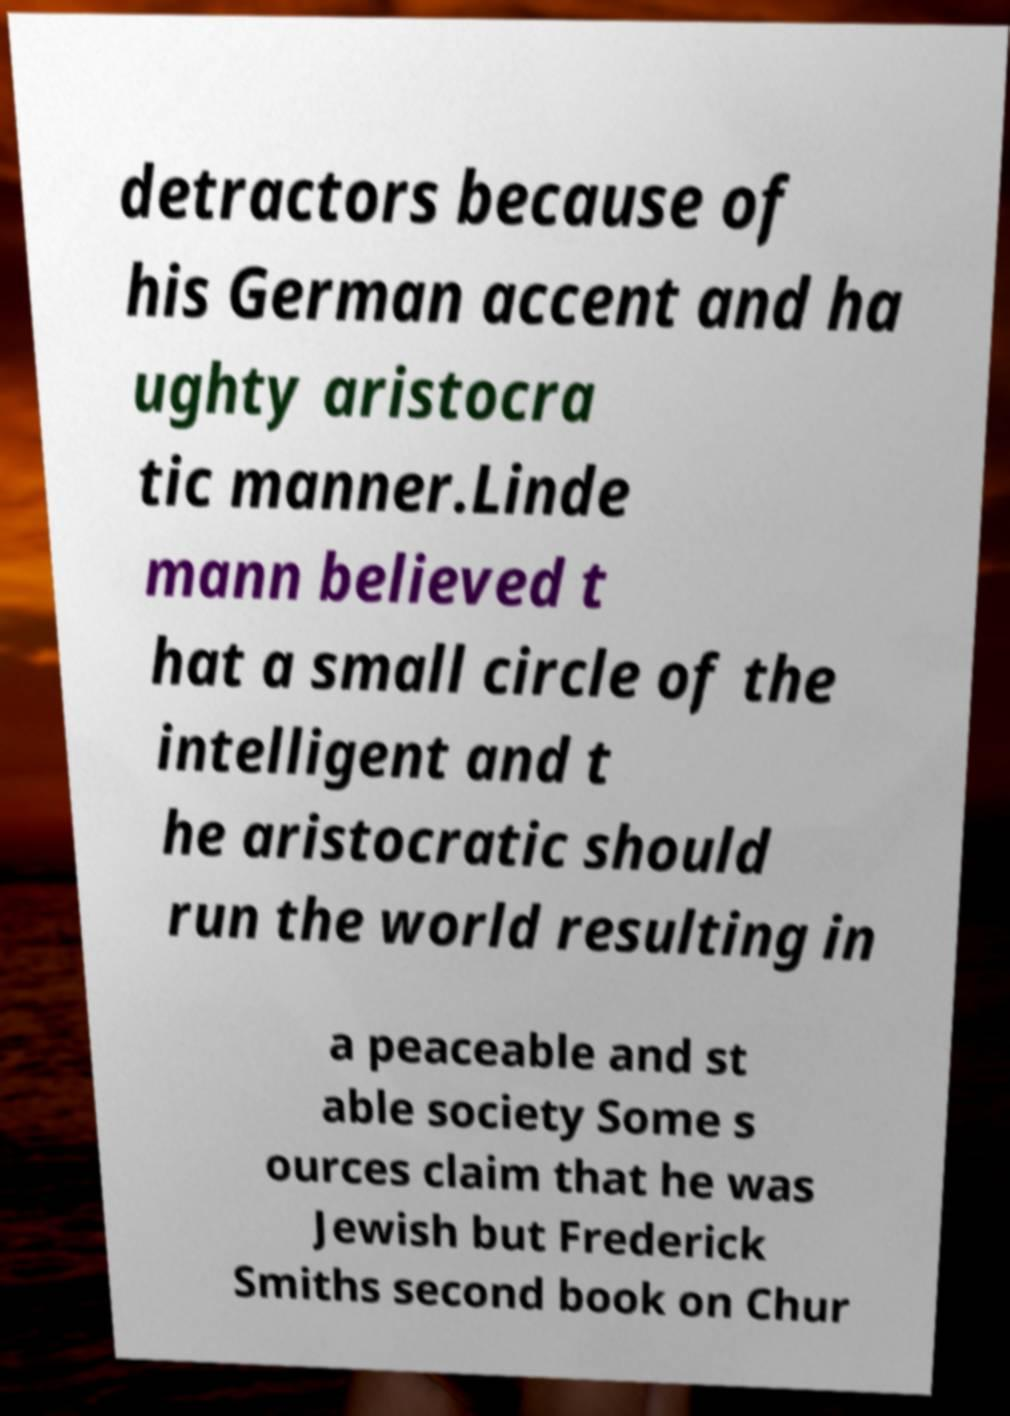What messages or text are displayed in this image? I need them in a readable, typed format. detractors because of his German accent and ha ughty aristocra tic manner.Linde mann believed t hat a small circle of the intelligent and t he aristocratic should run the world resulting in a peaceable and st able society Some s ources claim that he was Jewish but Frederick Smiths second book on Chur 